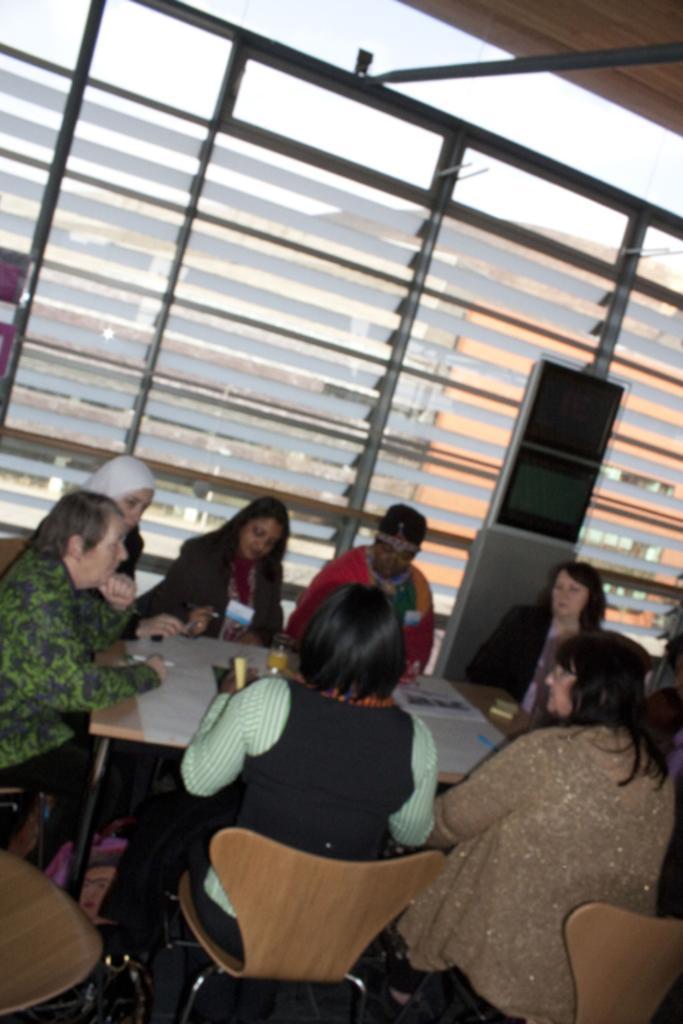Could you give a brief overview of what you see in this image? In this image we can see people sitting on the chairs around the table. In the background we can see glass windows. 